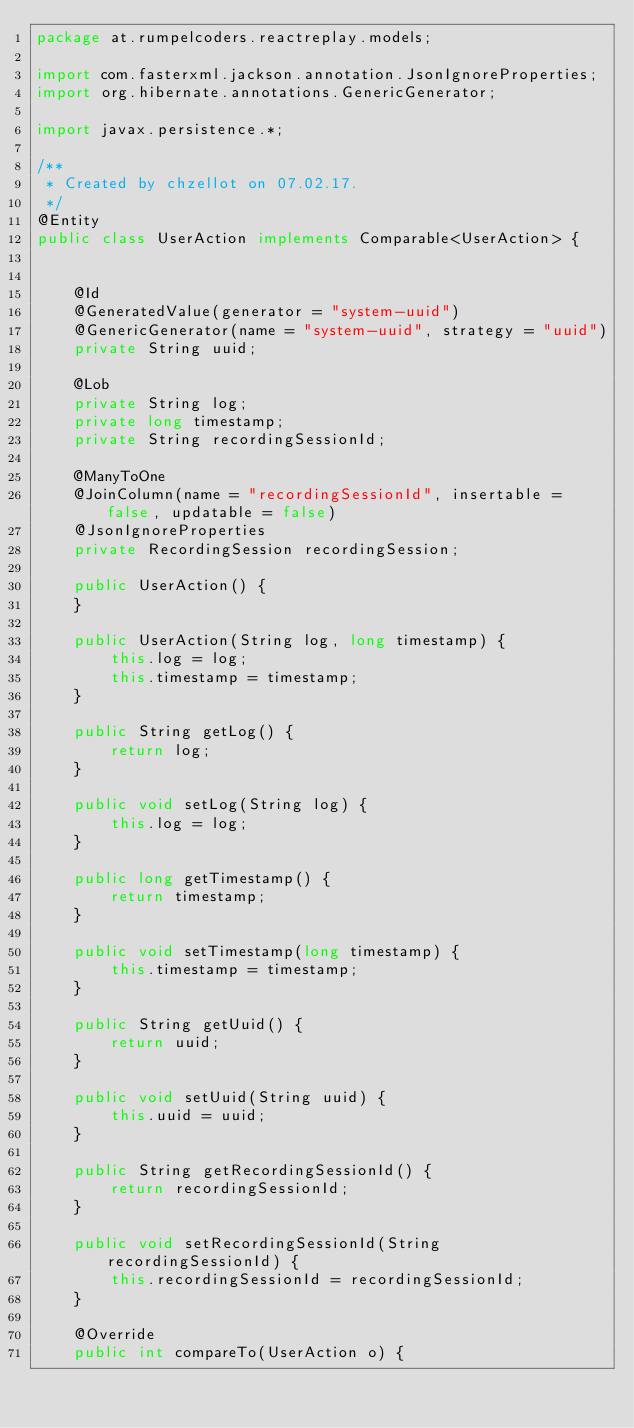Convert code to text. <code><loc_0><loc_0><loc_500><loc_500><_Java_>package at.rumpelcoders.reactreplay.models;

import com.fasterxml.jackson.annotation.JsonIgnoreProperties;
import org.hibernate.annotations.GenericGenerator;

import javax.persistence.*;

/**
 * Created by chzellot on 07.02.17.
 */
@Entity
public class UserAction implements Comparable<UserAction> {


    @Id
    @GeneratedValue(generator = "system-uuid")
    @GenericGenerator(name = "system-uuid", strategy = "uuid")
    private String uuid;

    @Lob
    private String log;
    private long timestamp;
    private String recordingSessionId;

    @ManyToOne
    @JoinColumn(name = "recordingSessionId", insertable = false, updatable = false)
    @JsonIgnoreProperties
    private RecordingSession recordingSession;

    public UserAction() {
    }

    public UserAction(String log, long timestamp) {
        this.log = log;
        this.timestamp = timestamp;
    }

    public String getLog() {
        return log;
    }

    public void setLog(String log) {
        this.log = log;
    }

    public long getTimestamp() {
        return timestamp;
    }

    public void setTimestamp(long timestamp) {
        this.timestamp = timestamp;
    }

    public String getUuid() {
        return uuid;
    }

    public void setUuid(String uuid) {
        this.uuid = uuid;
    }

    public String getRecordingSessionId() {
        return recordingSessionId;
    }

    public void setRecordingSessionId(String recordingSessionId) {
        this.recordingSessionId = recordingSessionId;
    }

    @Override
    public int compareTo(UserAction o) {</code> 